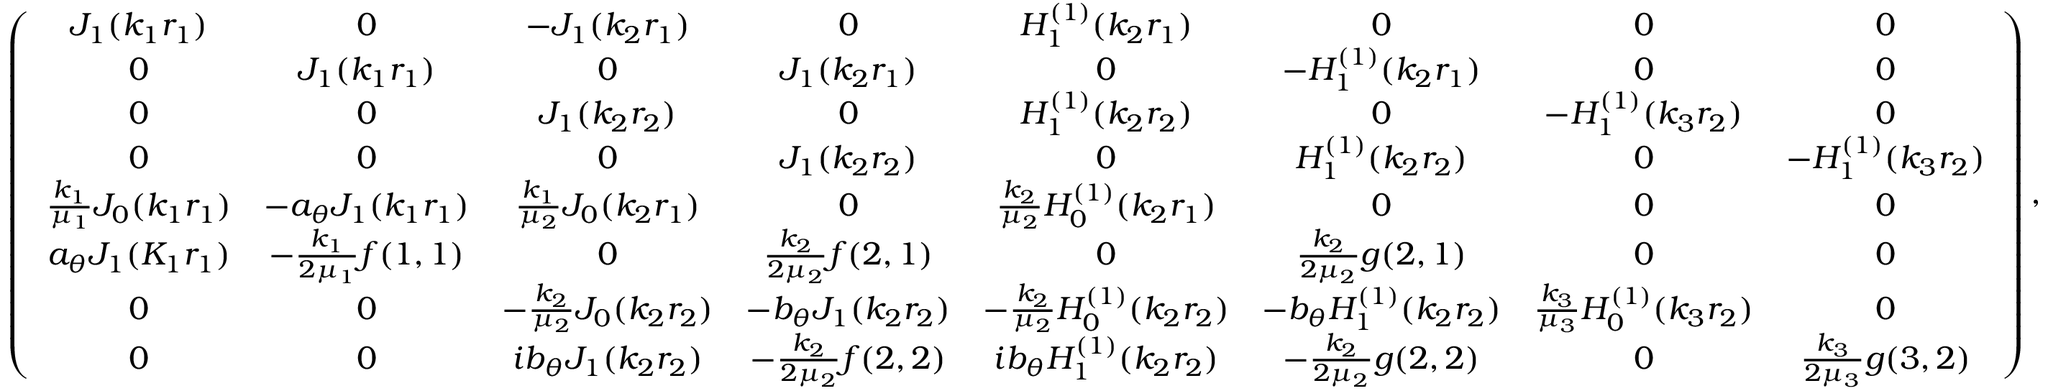Convert formula to latex. <formula><loc_0><loc_0><loc_500><loc_500>\left ( \begin{array} { c c c c c c c c } { J _ { 1 } ( k _ { 1 } r _ { 1 } ) } & { 0 } & { - J _ { 1 } ( k _ { 2 } r _ { 1 } ) } & { 0 } & { H _ { 1 } ^ { ( 1 ) } ( k _ { 2 } r _ { 1 } ) } & { 0 } & { 0 } & { 0 } \\ { 0 } & { J _ { 1 } ( k _ { 1 } r _ { 1 } ) } & { 0 } & { J _ { 1 } ( k _ { 2 } r _ { 1 } ) } & { 0 } & { - H _ { 1 } ^ { ( 1 ) } ( k _ { 2 } r _ { 1 } ) } & { 0 } & { 0 } \\ { 0 } & { 0 } & { J _ { 1 } ( k _ { 2 } r _ { 2 } ) } & { 0 } & { H _ { 1 } ^ { ( 1 ) } ( k _ { 2 } r _ { 2 } ) } & { 0 } & { - H _ { 1 } ^ { ( 1 ) } ( k _ { 3 } r _ { 2 } ) } & { 0 } \\ { 0 } & { 0 } & { 0 } & { J _ { 1 } ( k _ { 2 } r _ { 2 } ) } & { 0 } & { H _ { 1 } ^ { ( 1 ) } ( k _ { 2 } r _ { 2 } ) } & { 0 } & { - H _ { 1 } ^ { ( 1 ) } ( k _ { 3 } r _ { 2 } ) } \\ { \frac { k _ { 1 } } { \mu _ { 1 } } J _ { 0 } ( k _ { 1 } r _ { 1 } ) } & { - a _ { \theta } J _ { 1 } ( k _ { 1 } r _ { 1 } ) } & { \frac { k _ { 1 } } { \mu _ { 2 } } J _ { 0 } ( k _ { 2 } r _ { 1 } ) } & { 0 } & { \frac { k _ { 2 } } { \mu _ { 2 } } H _ { 0 } ^ { ( 1 ) } ( k _ { 2 } r _ { 1 } ) } & { 0 } & { 0 } & { 0 } \\ { a _ { \theta } J _ { 1 } ( K _ { 1 } r _ { 1 } ) } & { - \frac { k _ { 1 } } { 2 \mu _ { 1 } } f ( 1 , 1 ) } & { 0 } & { \frac { k _ { 2 } } { 2 \mu _ { 2 } } f ( 2 , 1 ) } & { 0 } & { \frac { k _ { 2 } } { 2 \mu _ { 2 } } g ( 2 , 1 ) } & { 0 } & { 0 } \\ { 0 } & { 0 } & { - \frac { k _ { 2 } } { \mu _ { 2 } } J _ { 0 } ( k _ { 2 } r _ { 2 } ) } & { - b _ { \theta } J _ { 1 } ( k _ { 2 } r _ { 2 } ) } & { - \frac { k _ { 2 } } { \mu _ { 2 } } H _ { 0 } ^ { ( 1 ) } ( k _ { 2 } r _ { 2 } ) } & { - b _ { \theta } H _ { 1 } ^ { ( 1 ) } ( k _ { 2 } r _ { 2 } ) } & { \frac { k _ { 3 } } { \mu _ { 3 } } H _ { 0 } ^ { ( 1 ) } ( k _ { 3 } r _ { 2 } ) } & { 0 } \\ { 0 } & { 0 } & { i b _ { \theta } J _ { 1 } ( k _ { 2 } r _ { 2 } ) } & { - \frac { k _ { 2 } } { 2 \mu _ { 2 } } f ( 2 , 2 ) } & { i b _ { \theta } H _ { 1 } ^ { ( 1 ) } ( k _ { 2 } r _ { 2 } ) } & { - \frac { k _ { 2 } } { 2 \mu _ { 2 } } g ( 2 , 2 ) } & { 0 } & { \frac { k _ { 3 } } { 2 \mu _ { 3 } } g ( 3 , 2 ) } \end{array} \right ) ,</formula> 